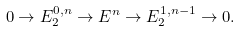Convert formula to latex. <formula><loc_0><loc_0><loc_500><loc_500>0 \rightarrow E _ { 2 } ^ { 0 , n } \rightarrow E ^ { n } \rightarrow E _ { 2 } ^ { 1 , n - 1 } \rightarrow 0 .</formula> 